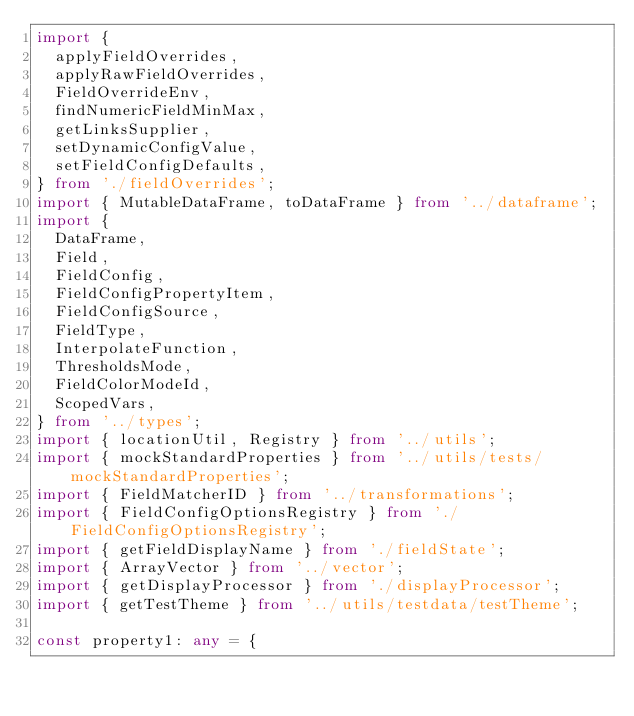<code> <loc_0><loc_0><loc_500><loc_500><_TypeScript_>import {
  applyFieldOverrides,
  applyRawFieldOverrides,
  FieldOverrideEnv,
  findNumericFieldMinMax,
  getLinksSupplier,
  setDynamicConfigValue,
  setFieldConfigDefaults,
} from './fieldOverrides';
import { MutableDataFrame, toDataFrame } from '../dataframe';
import {
  DataFrame,
  Field,
  FieldConfig,
  FieldConfigPropertyItem,
  FieldConfigSource,
  FieldType,
  InterpolateFunction,
  ThresholdsMode,
  FieldColorModeId,
  ScopedVars,
} from '../types';
import { locationUtil, Registry } from '../utils';
import { mockStandardProperties } from '../utils/tests/mockStandardProperties';
import { FieldMatcherID } from '../transformations';
import { FieldConfigOptionsRegistry } from './FieldConfigOptionsRegistry';
import { getFieldDisplayName } from './fieldState';
import { ArrayVector } from '../vector';
import { getDisplayProcessor } from './displayProcessor';
import { getTestTheme } from '../utils/testdata/testTheme';

const property1: any = {</code> 